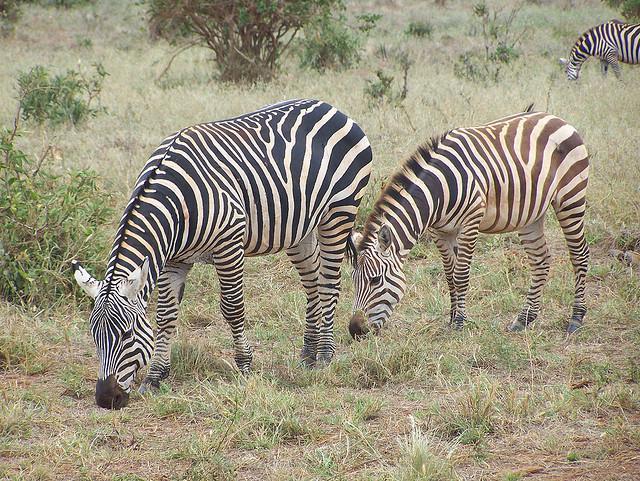How many zebras are in this picture?
Give a very brief answer. 3. How many zebras are there?
Give a very brief answer. 3. How many elephants are in the picture?
Give a very brief answer. 0. 